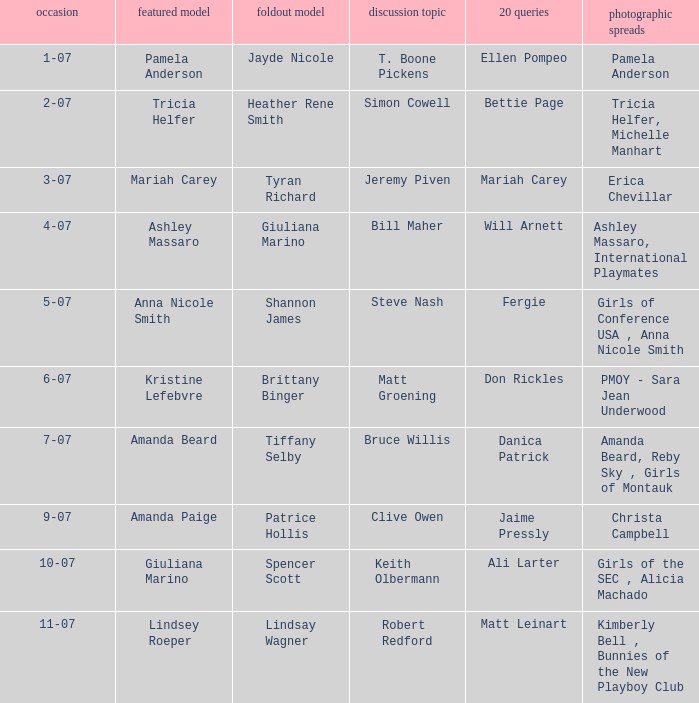Itemize the images from publications when lindsey roeper appeared as the cover model. Kimberly Bell , Bunnies of the New Playboy Club. 